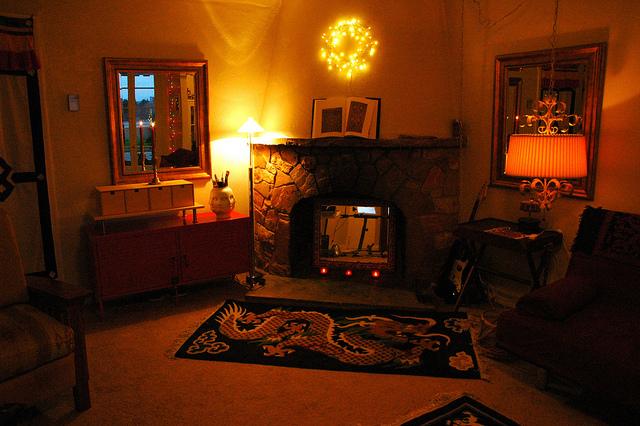How many mirrors in the room?
Be succinct. 2. Are the lights on?
Be succinct. Yes. Where is a musical instrument?
Quick response, please. Yes. 